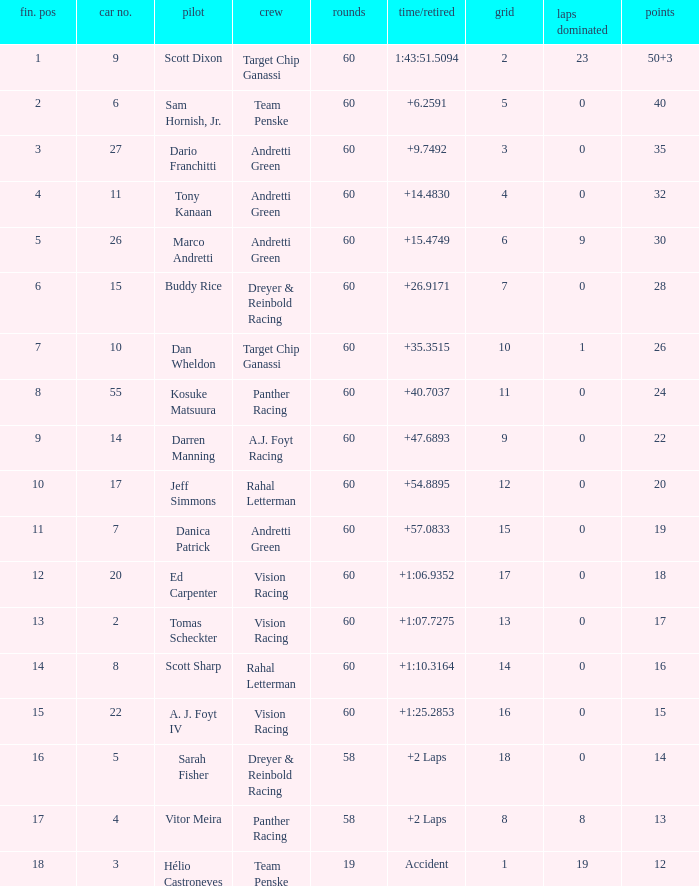Name the drive for points being 13 Vitor Meira. 